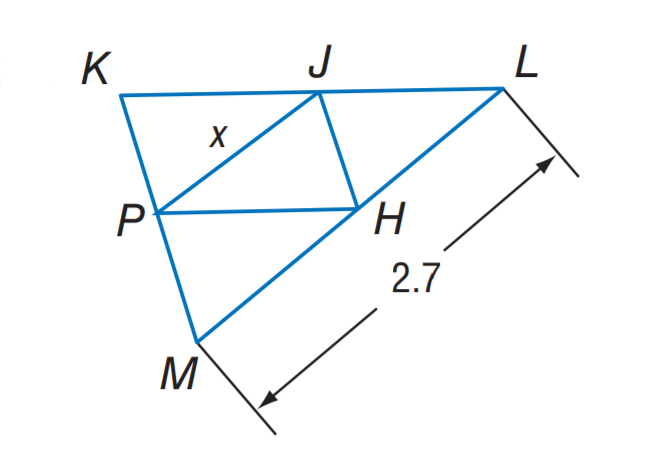Answer the mathemtical geometry problem and directly provide the correct option letter.
Question: J H, J P, and P H are midsegments of \triangle K L M. Find x.
Choices: A: 1.05 B: 1.35 C: 2.1 D: 2.7 B 